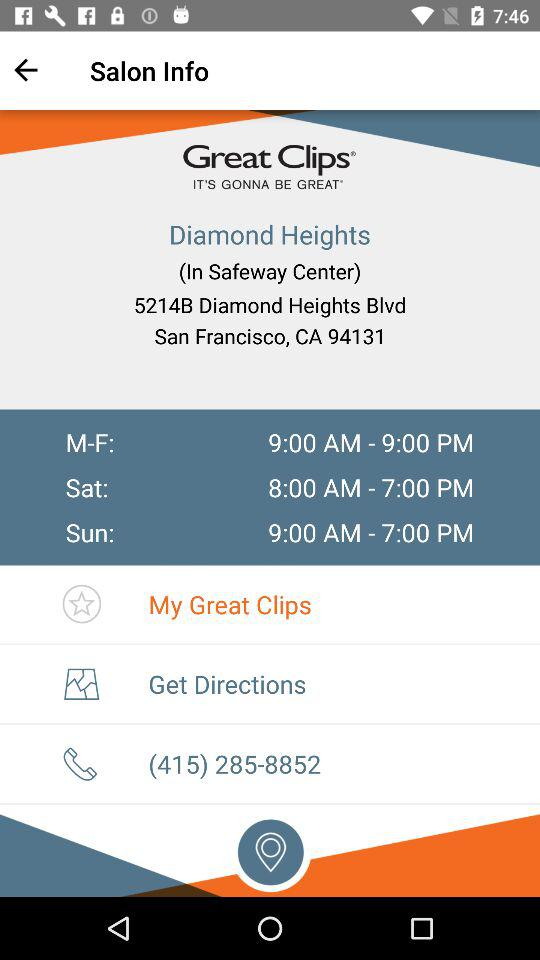What is the address? The address is 5214B Diamond Heights Blvd San Francisco, CA 94131. 